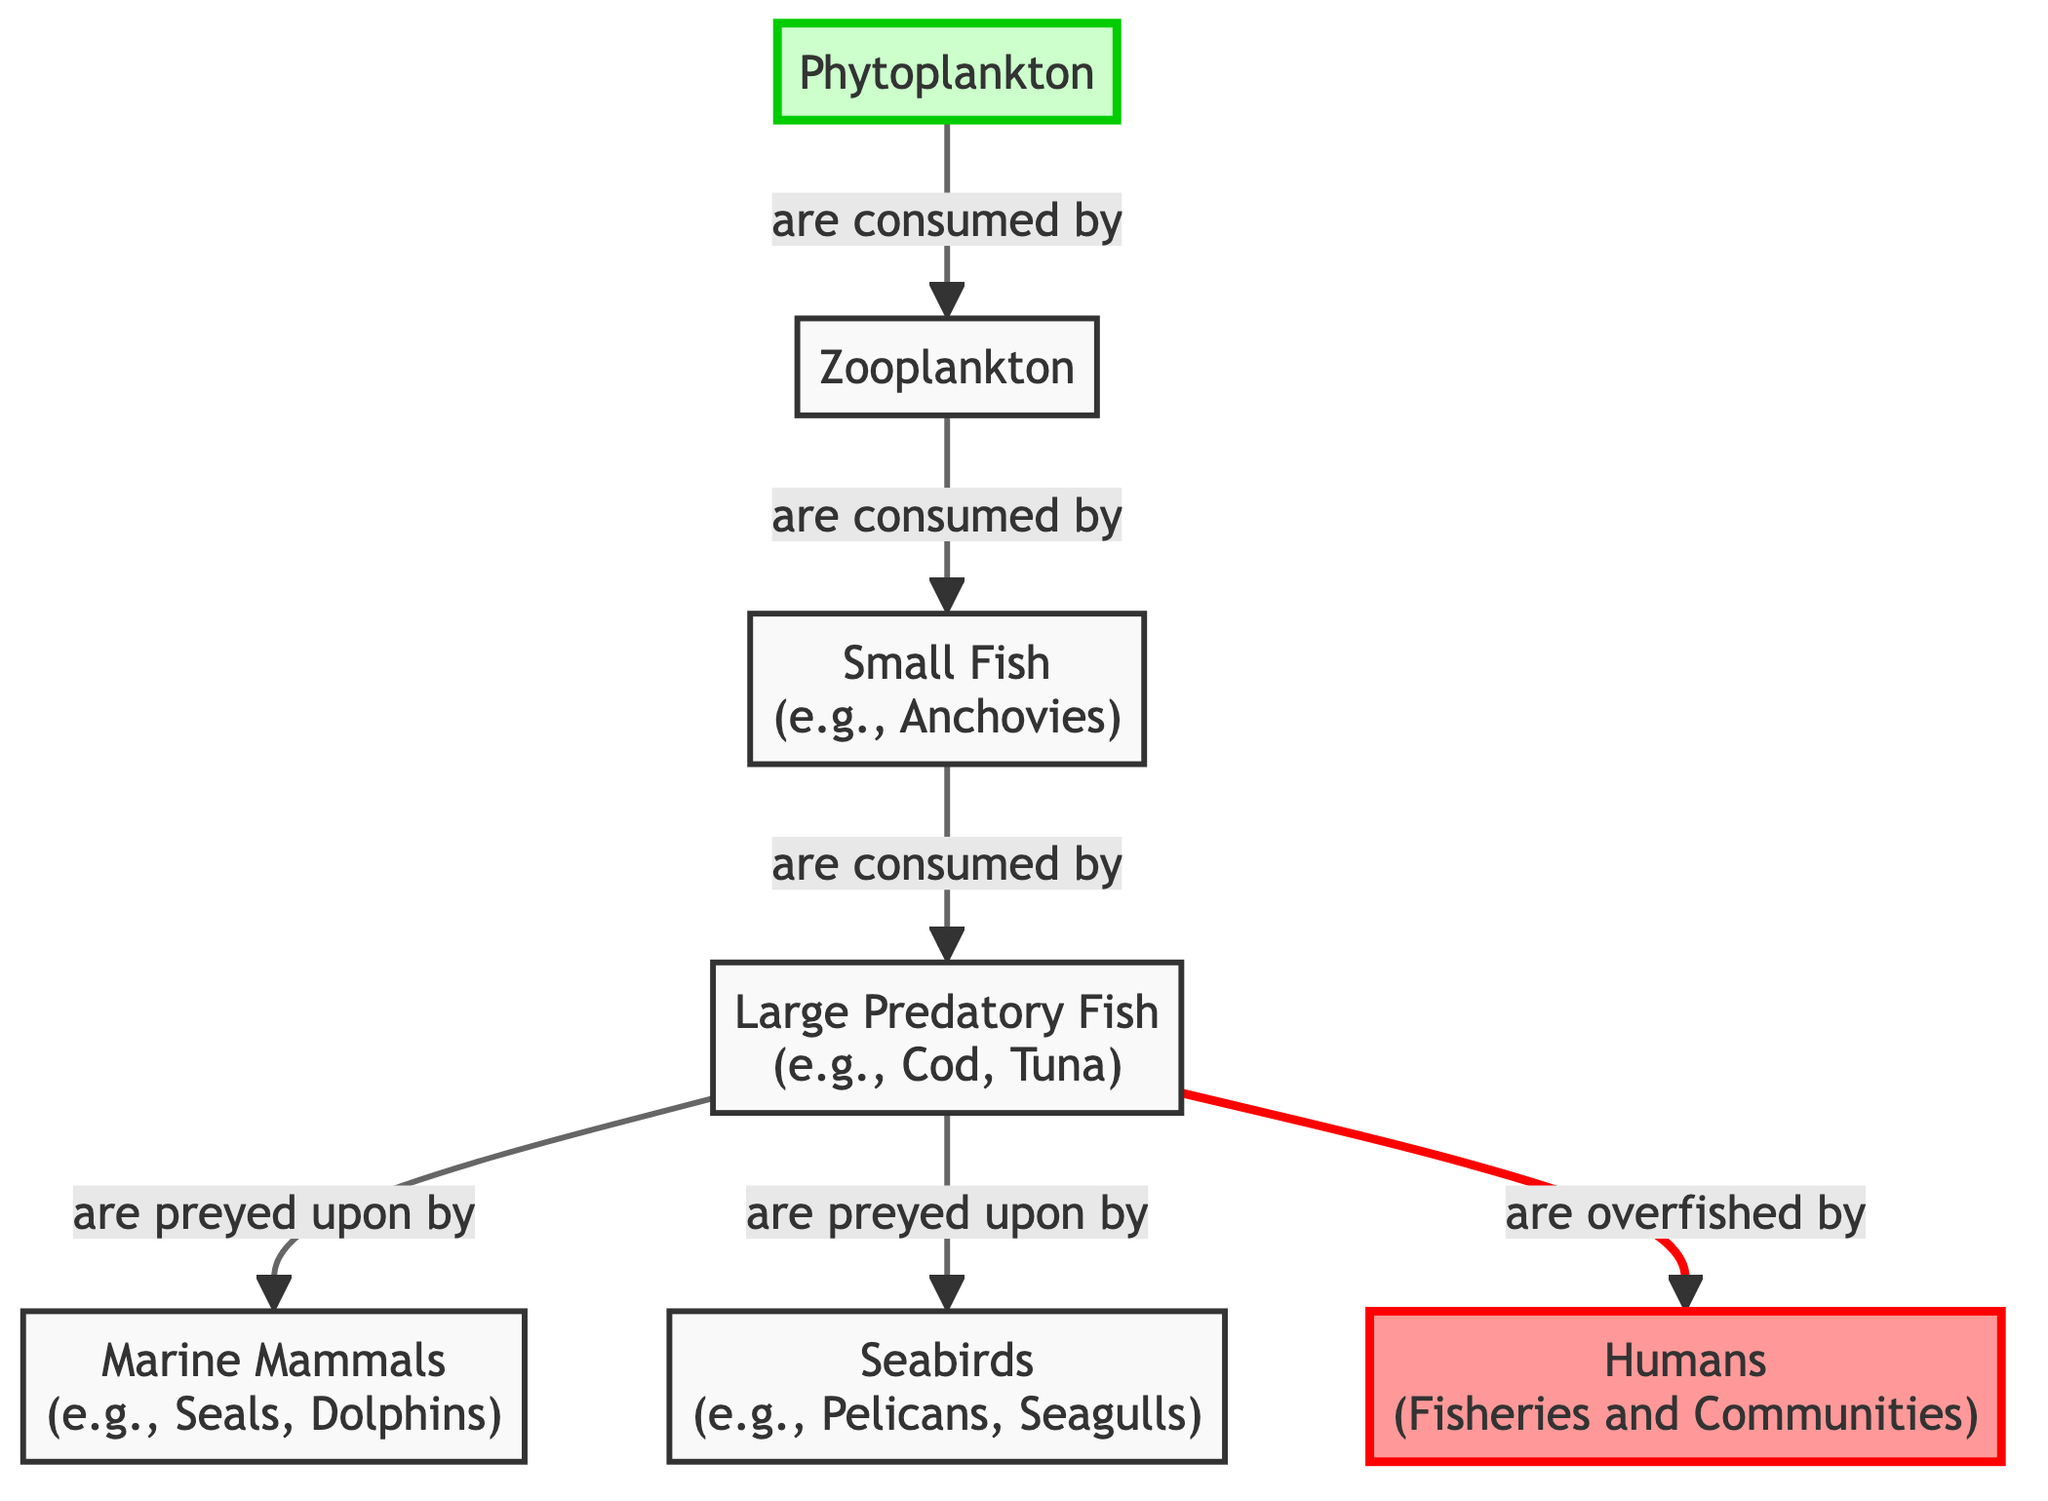What is at the base of the food chain? The base of the food chain is represented by the node that has no incoming arrows. In this diagram, "Phytoplankton" is the first node and does not receive any other inputs, indicating it is the starting point for energy flow in this ecosystem.
Answer: Phytoplankton How many types of fish are in the diagram? To answer this, I look at the nodes labeled specifically as fish. There are two types of fish indicated: "Small Fish" and "Large Predatory Fish." Therefore, I count these nodes to find the total number of unique fish types in the food chain.
Answer: 2 What do large predatory fish prey on? I need to consider the outgoing edges from the node labeled "Large Predatory Fish." The diagram indicates that they are preyed upon by two distinct groups: "Marine Mammals" and "Seabirds." Thus, I list these two categories to answer the question.
Answer: Marine Mammals and Seabirds Who overfishes the large predatory fish? In the diagram, "Humans" is the node that has a directed edge labeled "are overfished by" pointing to the "Large Predatory Fish." This straightforward relationship indicates the interaction characterized by overfishing.
Answer: Humans What level of the food chain is zooplankton? To determine the level of the "Zooplankton" node, I follow the arrows leading to and from it. "Zooplankton" consumes "Phytoplankton" (1st level) and is then consumed by "Small Fish" (2nd level). Based on this information, I classify zooplankton’s position in the hierarchy of the food chain.
Answer: 2nd level Which organisms are directly impacted by overfishing? To identify the organisms affected directly by overfishing, I need to look at the "Large Predatory Fish" node as it is the focus of the overfishing interaction. Both categories, "Marine Mammals" and "Seabirds," rely on "Large Predatory Fish" as a food source; hence, they are indirectly affected. However, only the large predatory fish are overfished by humans.
Answer: Large Predatory Fish How many organisms eat zooplankton? I will trace the connections from the "Zooplankton" node. It has one outgoing relationship that shows "Zooplankton" is consumed by "Small Fish." Counting these connections gives me the total number of organisms that consume Zooplankton.
Answer: 1 What is the role of phytoplankton in this ecosystem? The role of "Phytoplankton" can be found by checking which node consumes it. It is at the first level of the food chain and serves as a primary producer. The outgoing edge indicates its function as a food source for "Zooplankton," thus highlighting its critical role in energy flow within the ecosystem.
Answer: Primary producer How many arrows point towards large predatory fish? To answer this, I must examine the edges marked towards the "Large Predatory Fish." There are two incoming arrows; one comes from "Small Fish" (as it preys upon them), and the other from "Humans" (who overfish the large predatory fish). Therefore, I count these incoming connections to determine the correct number.
Answer: 2 